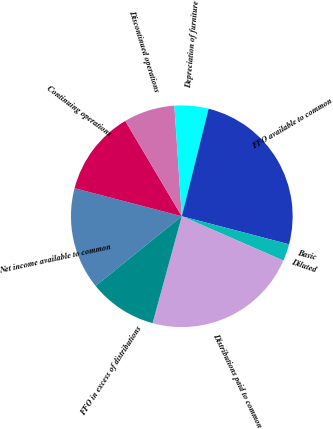Convert chart. <chart><loc_0><loc_0><loc_500><loc_500><pie_chart><fcel>Net income available to common<fcel>Continuing operations<fcel>Discontinued operations<fcel>Depreciation of furniture<fcel>FFO available to common<fcel>Basic<fcel>Diluted<fcel>Distributions paid to common<fcel>FFO in excess of distributions<nl><fcel>14.89%<fcel>12.41%<fcel>7.45%<fcel>4.96%<fcel>25.18%<fcel>0.0%<fcel>2.48%<fcel>22.7%<fcel>9.93%<nl></chart> 